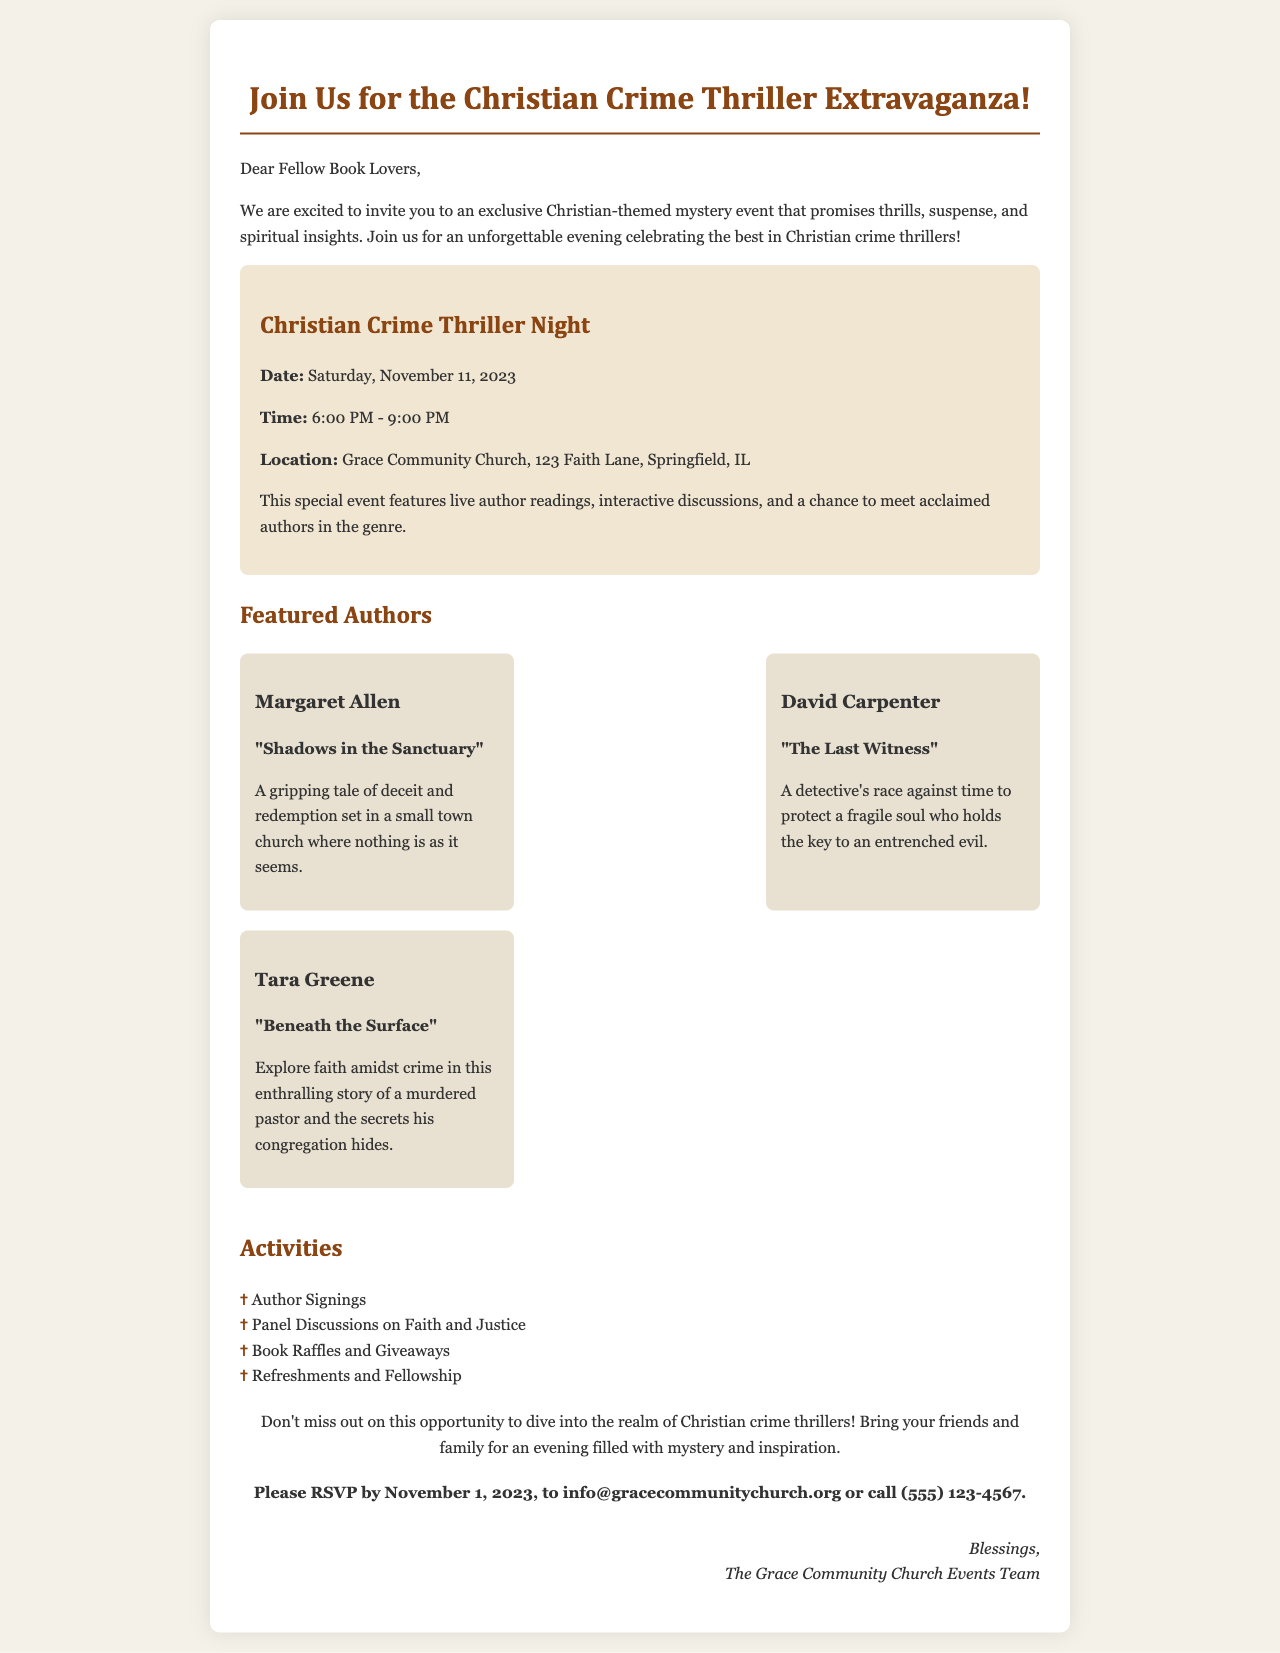What is the date of the event? The date of the event is presented in the document as Saturday, November 11, 2023.
Answer: Saturday, November 11, 2023 What location is the event being held at? The location of the event is prominently mentioned in the document as Grace Community Church, 123 Faith Lane, Springfield, IL.
Answer: Grace Community Church, 123 Faith Lane, Springfield, IL Who is the author of "Shadows in the Sanctuary"? The author of "Shadows in the Sanctuary" is mentioned in the featured authors section as Margaret Allen.
Answer: Margaret Allen What types of activities will be at the event? The document lists activities that include author signings, panel discussions, book raffles, and refreshments.
Answer: Author Signings, Panel Discussions on Faith and Justice, Book Raffles and Giveaways, Refreshments and Fellowship What is the RSVP deadline? The RSVP deadline is specified in the document as November 1, 2023.
Answer: November 1, 2023 What is the time frame for the event? The time frame for the event is detailed in the document as 6:00 PM - 9:00 PM.
Answer: 6:00 PM - 9:00 PM How many featured authors are listed? The number of featured authors is derived from the document where it mentions three authors: Margaret Allen, David Carpenter, and Tara Greene.
Answer: Three What is the main theme of the event? The main theme of the event is indicated in various parts of the document, specifically highlighting Christian-themed mystery and crime thrillers.
Answer: Christian-themed mystery and crime thrillers 